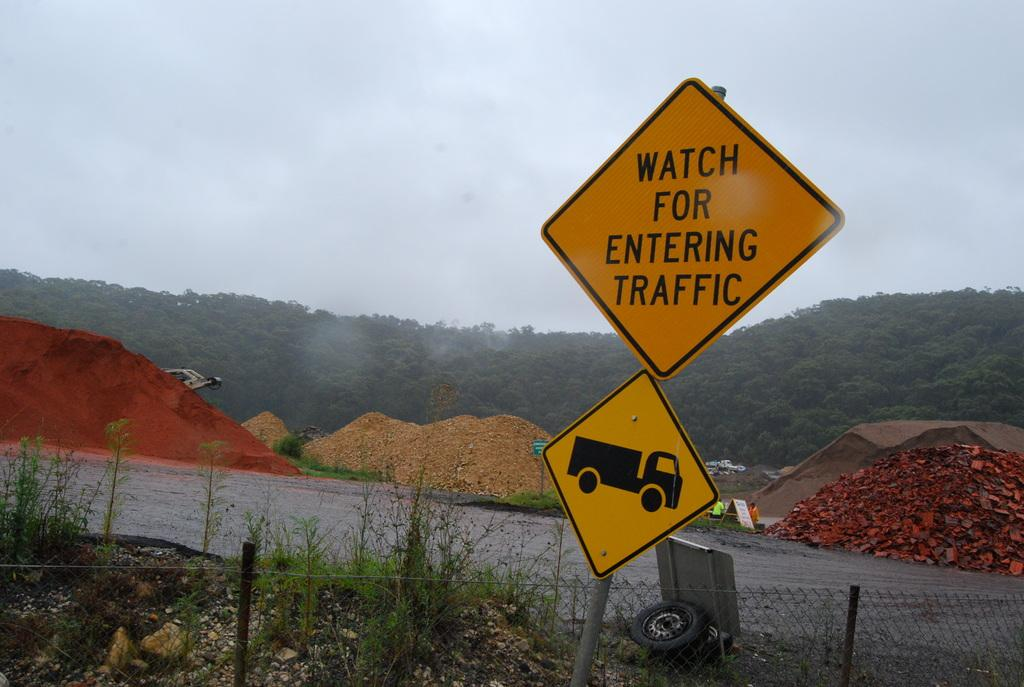Provide a one-sentence caption for the provided image. A yellow sign warns to watch for entering for traffic. 